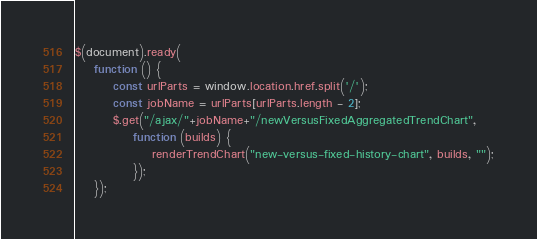<code> <loc_0><loc_0><loc_500><loc_500><_JavaScript_>$(document).ready(
    function () {
        const urlParts = window.location.href.split('/');
        const jobName = urlParts[urlParts.length - 2];
        $.get("/ajax/"+jobName+"/newVersusFixedAggregatedTrendChart",
            function (builds) {
                renderTrendChart("new-versus-fixed-history-chart", builds, "");
            });
    });</code> 